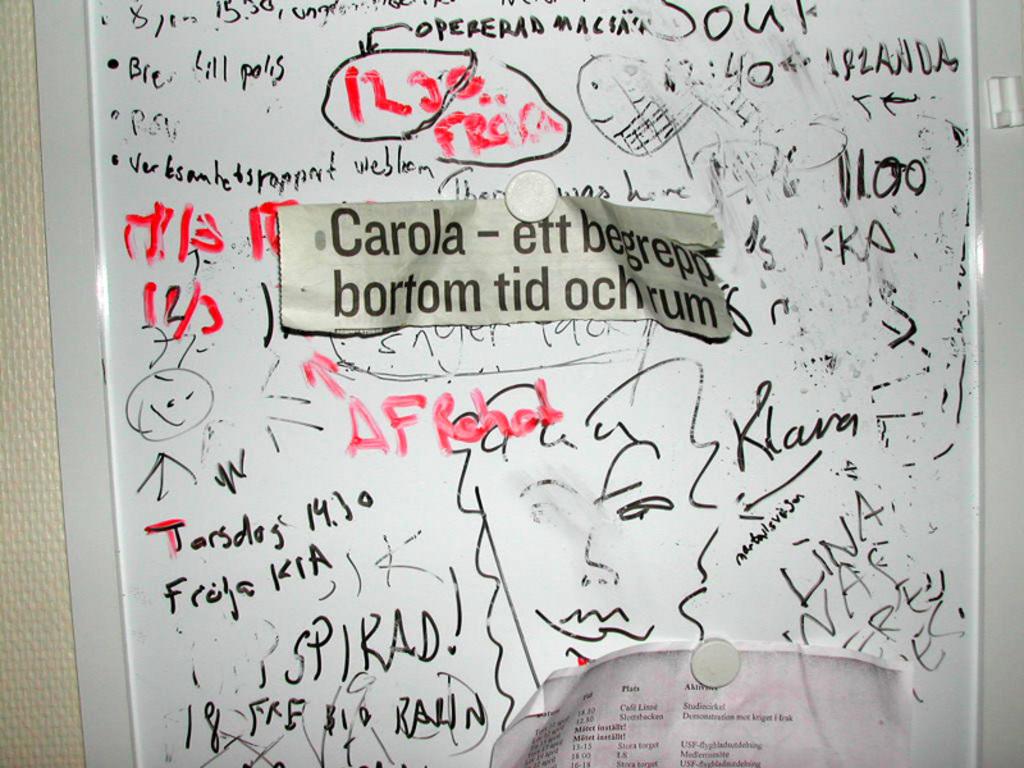What is written on the piece of paper tagged on the board?
Keep it short and to the point. Carola - ett begrepp bortom tid ochrum. What word is in red with a red arrow beside it?
Offer a terse response. Afrohol. 